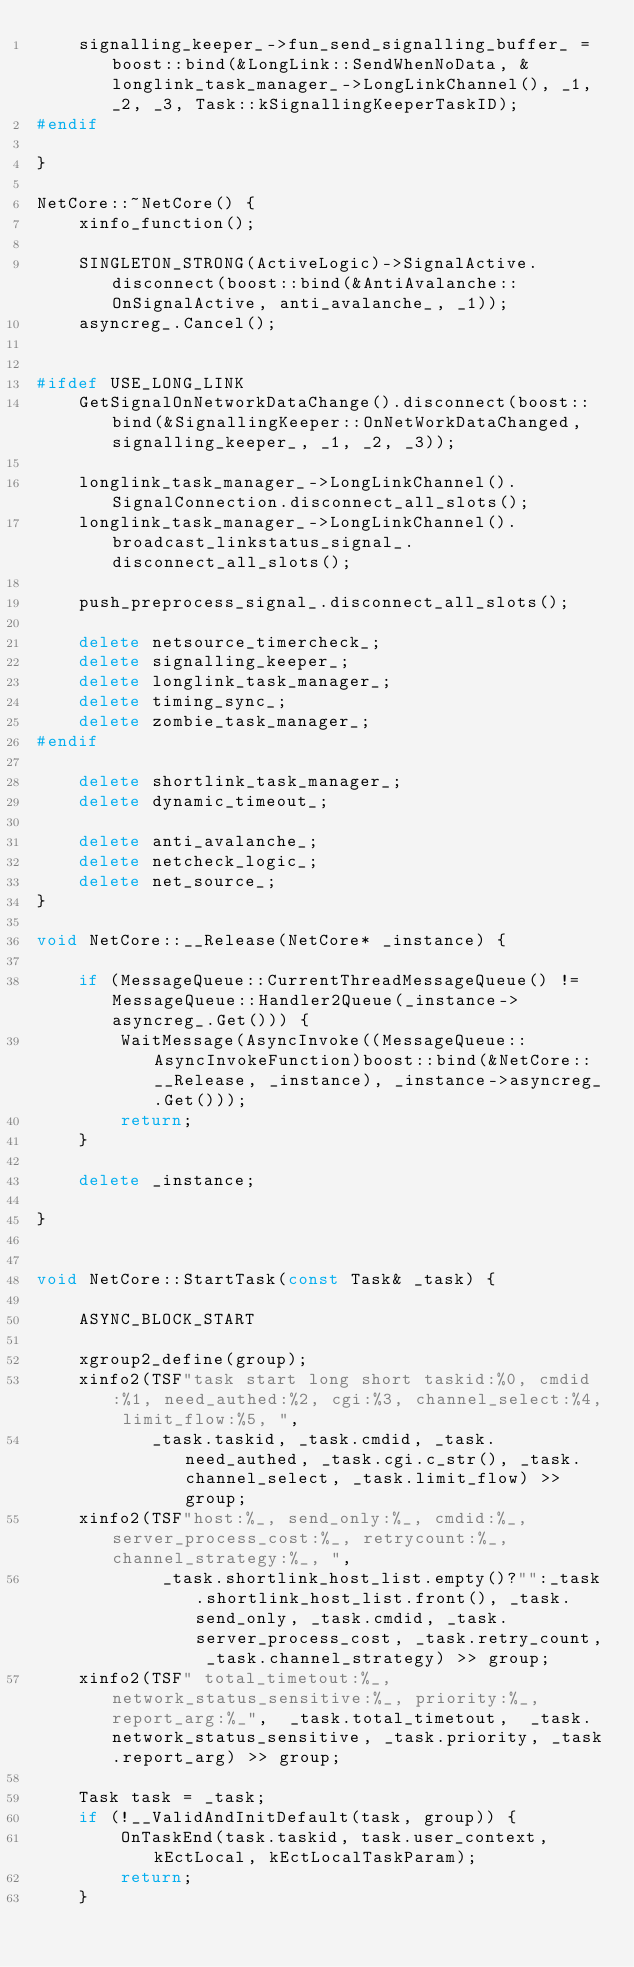<code> <loc_0><loc_0><loc_500><loc_500><_C++_>	signalling_keeper_->fun_send_signalling_buffer_ = boost::bind(&LongLink::SendWhenNoData, &longlink_task_manager_->LongLinkChannel(), _1, _2, _3, Task::kSignallingKeeperTaskID);
#endif

}

NetCore::~NetCore() {
    xinfo_function();

    SINGLETON_STRONG(ActiveLogic)->SignalActive.disconnect(boost::bind(&AntiAvalanche::OnSignalActive, anti_avalanche_, _1));
    asyncreg_.Cancel();


#ifdef USE_LONG_LINK
    GetSignalOnNetworkDataChange().disconnect(boost::bind(&SignallingKeeper::OnNetWorkDataChanged, signalling_keeper_, _1, _2, _3));
    
    longlink_task_manager_->LongLinkChannel().SignalConnection.disconnect_all_slots();
    longlink_task_manager_->LongLinkChannel().broadcast_linkstatus_signal_.disconnect_all_slots();

    push_preprocess_signal_.disconnect_all_slots();

    delete netsource_timercheck_;
    delete signalling_keeper_;
    delete longlink_task_manager_;
    delete timing_sync_;
    delete zombie_task_manager_;
#endif

    delete shortlink_task_manager_;
    delete dynamic_timeout_;
    
    delete anti_avalanche_;
    delete netcheck_logic_;
    delete net_source_;
}

void NetCore::__Release(NetCore* _instance) {
    
    if (MessageQueue::CurrentThreadMessageQueue() != MessageQueue::Handler2Queue(_instance->asyncreg_.Get())) {
        WaitMessage(AsyncInvoke((MessageQueue::AsyncInvokeFunction)boost::bind(&NetCore::__Release, _instance), _instance->asyncreg_.Get()));
        return;
    }
 
    delete _instance;

}


void NetCore::StartTask(const Task& _task) {
    
    ASYNC_BLOCK_START

    xgroup2_define(group);
    xinfo2(TSF"task start long short taskid:%0, cmdid:%1, need_authed:%2, cgi:%3, channel_select:%4, limit_flow:%5, ",
           _task.taskid, _task.cmdid, _task.need_authed, _task.cgi.c_str(), _task.channel_select, _task.limit_flow) >> group;
    xinfo2(TSF"host:%_, send_only:%_, cmdid:%_, server_process_cost:%_, retrycount:%_,  channel_strategy:%_, ",
    		_task.shortlink_host_list.empty()?"":_task.shortlink_host_list.front(), _task.send_only, _task.cmdid, _task.server_process_cost, _task.retry_count, _task.channel_strategy) >> group;
    xinfo2(TSF" total_timetout:%_, network_status_sensitive:%_, priority:%_, report_arg:%_",  _task.total_timetout,  _task.network_status_sensitive, _task.priority, _task.report_arg) >> group;

    Task task = _task;
    if (!__ValidAndInitDefault(task, group)) {
        OnTaskEnd(task.taskid, task.user_context, kEctLocal, kEctLocalTaskParam);
        return;
    }
    </code> 